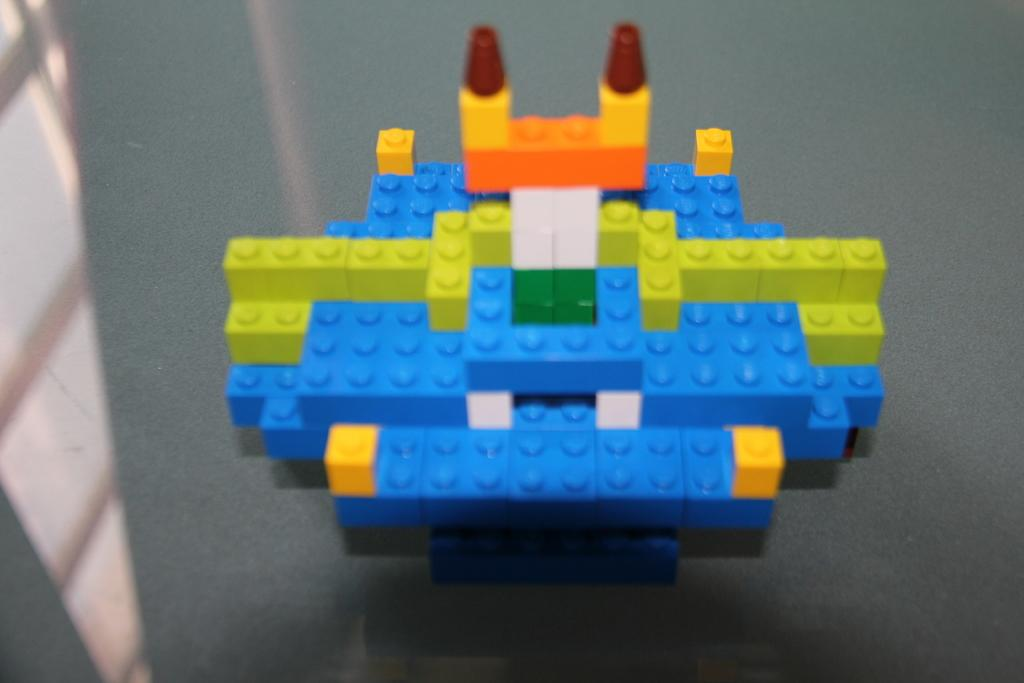What type of toys are on the table in the image? There are toy blocks on the table. Can you describe the appearance of the toy blocks? The toy blocks are in different colors. What can be seen in the reflection in the image? There is a window visible in the reflection. What type of yoke is visible in the image? There is no yoke present in the image. What liquid can be seen in the image? There is no liquid present in the image. 